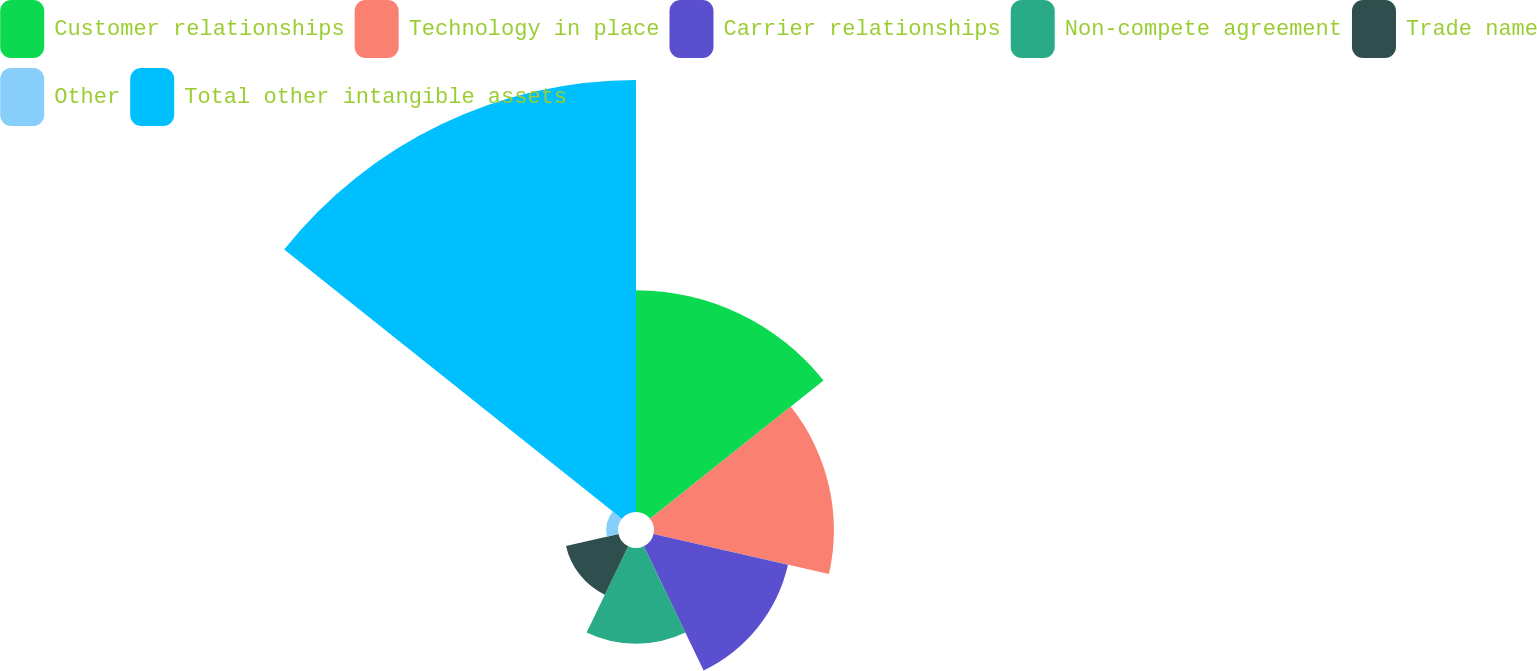Convert chart to OTSL. <chart><loc_0><loc_0><loc_500><loc_500><pie_chart><fcel>Customer relationships<fcel>Technology in place<fcel>Carrier relationships<fcel>Non-compete agreement<fcel>Trade name<fcel>Other<fcel>Total other intangible assets<nl><fcel>19.58%<fcel>15.88%<fcel>12.17%<fcel>8.46%<fcel>4.75%<fcel>1.04%<fcel>38.13%<nl></chart> 